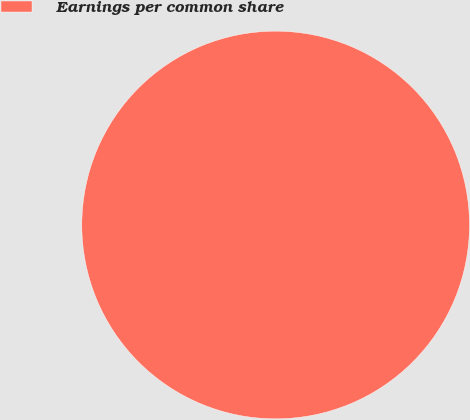<chart> <loc_0><loc_0><loc_500><loc_500><pie_chart><fcel>Earnings per common share<nl><fcel>100.0%<nl></chart> 